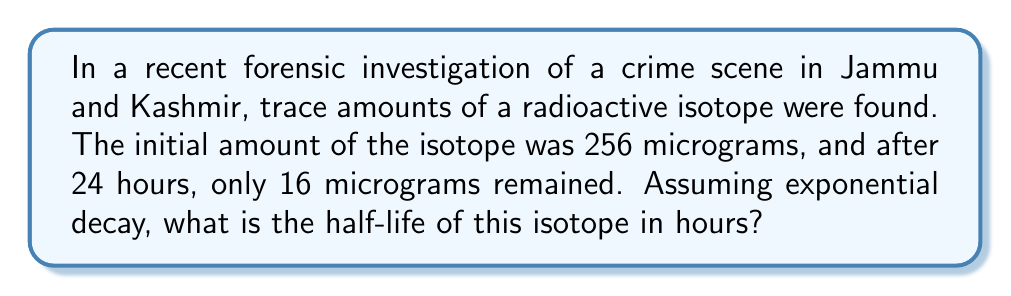Show me your answer to this math problem. Let's approach this step-by-step:

1) The exponential decay formula is:
   $$A(t) = A_0 \cdot e^{-\lambda t}$$
   where $A(t)$ is the amount at time $t$, $A_0$ is the initial amount, $\lambda$ is the decay constant, and $t$ is time.

2) We know:
   $A_0 = 256$ μg
   $A(24) = 16$ μg
   $t = 24$ hours

3) Substituting into the formula:
   $$16 = 256 \cdot e^{-24\lambda}$$

4) Dividing both sides by 256:
   $$\frac{1}{16} = e^{-24\lambda}$$

5) Taking natural log of both sides:
   $$\ln(\frac{1}{16}) = -24\lambda$$

6) Solving for $\lambda$:
   $$\lambda = -\frac{\ln(\frac{1}{16})}{24} = \frac{\ln(16)}{24} \approx 0.1155$$

7) The half-life formula is:
   $$t_{1/2} = \frac{\ln(2)}{\lambda}$$

8) Substituting our $\lambda$:
   $$t_{1/2} = \frac{\ln(2)}{\frac{\ln(16)}{24}} = \frac{24 \ln(2)}{\ln(16)} = 6$$

Therefore, the half-life of the isotope is 6 hours.
Answer: 6 hours 